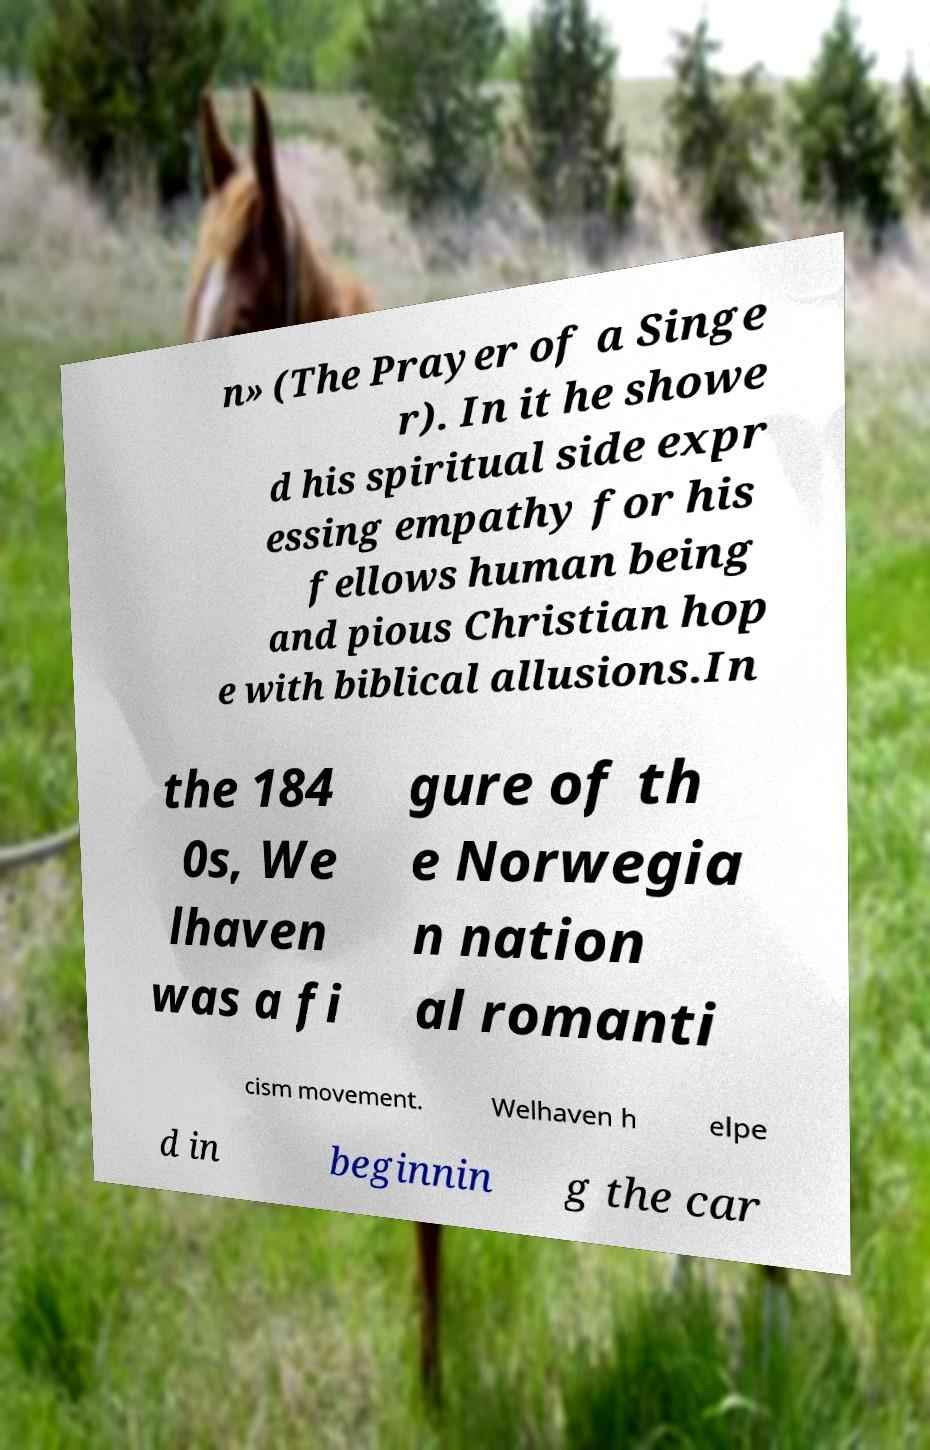For documentation purposes, I need the text within this image transcribed. Could you provide that? n» (The Prayer of a Singe r). In it he showe d his spiritual side expr essing empathy for his fellows human being and pious Christian hop e with biblical allusions.In the 184 0s, We lhaven was a fi gure of th e Norwegia n nation al romanti cism movement. Welhaven h elpe d in beginnin g the car 